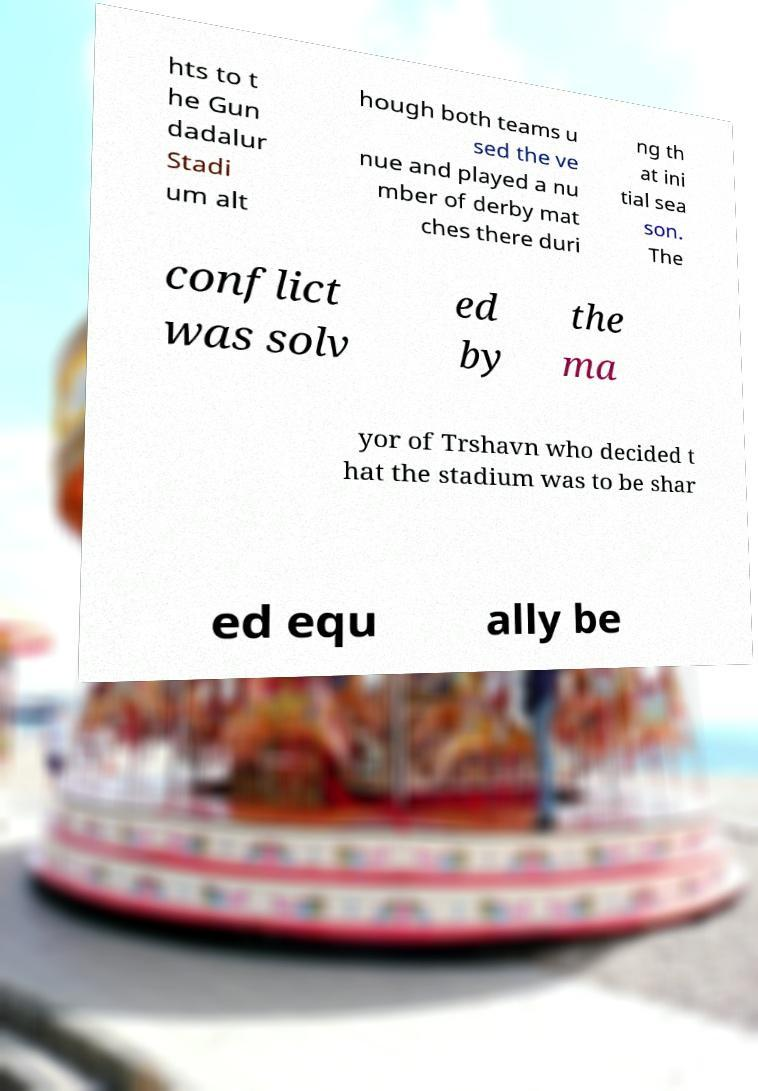Please read and relay the text visible in this image. What does it say? hts to t he Gun dadalur Stadi um alt hough both teams u sed the ve nue and played a nu mber of derby mat ches there duri ng th at ini tial sea son. The conflict was solv ed by the ma yor of Trshavn who decided t hat the stadium was to be shar ed equ ally be 